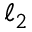<formula> <loc_0><loc_0><loc_500><loc_500>\ell _ { 2 }</formula> 